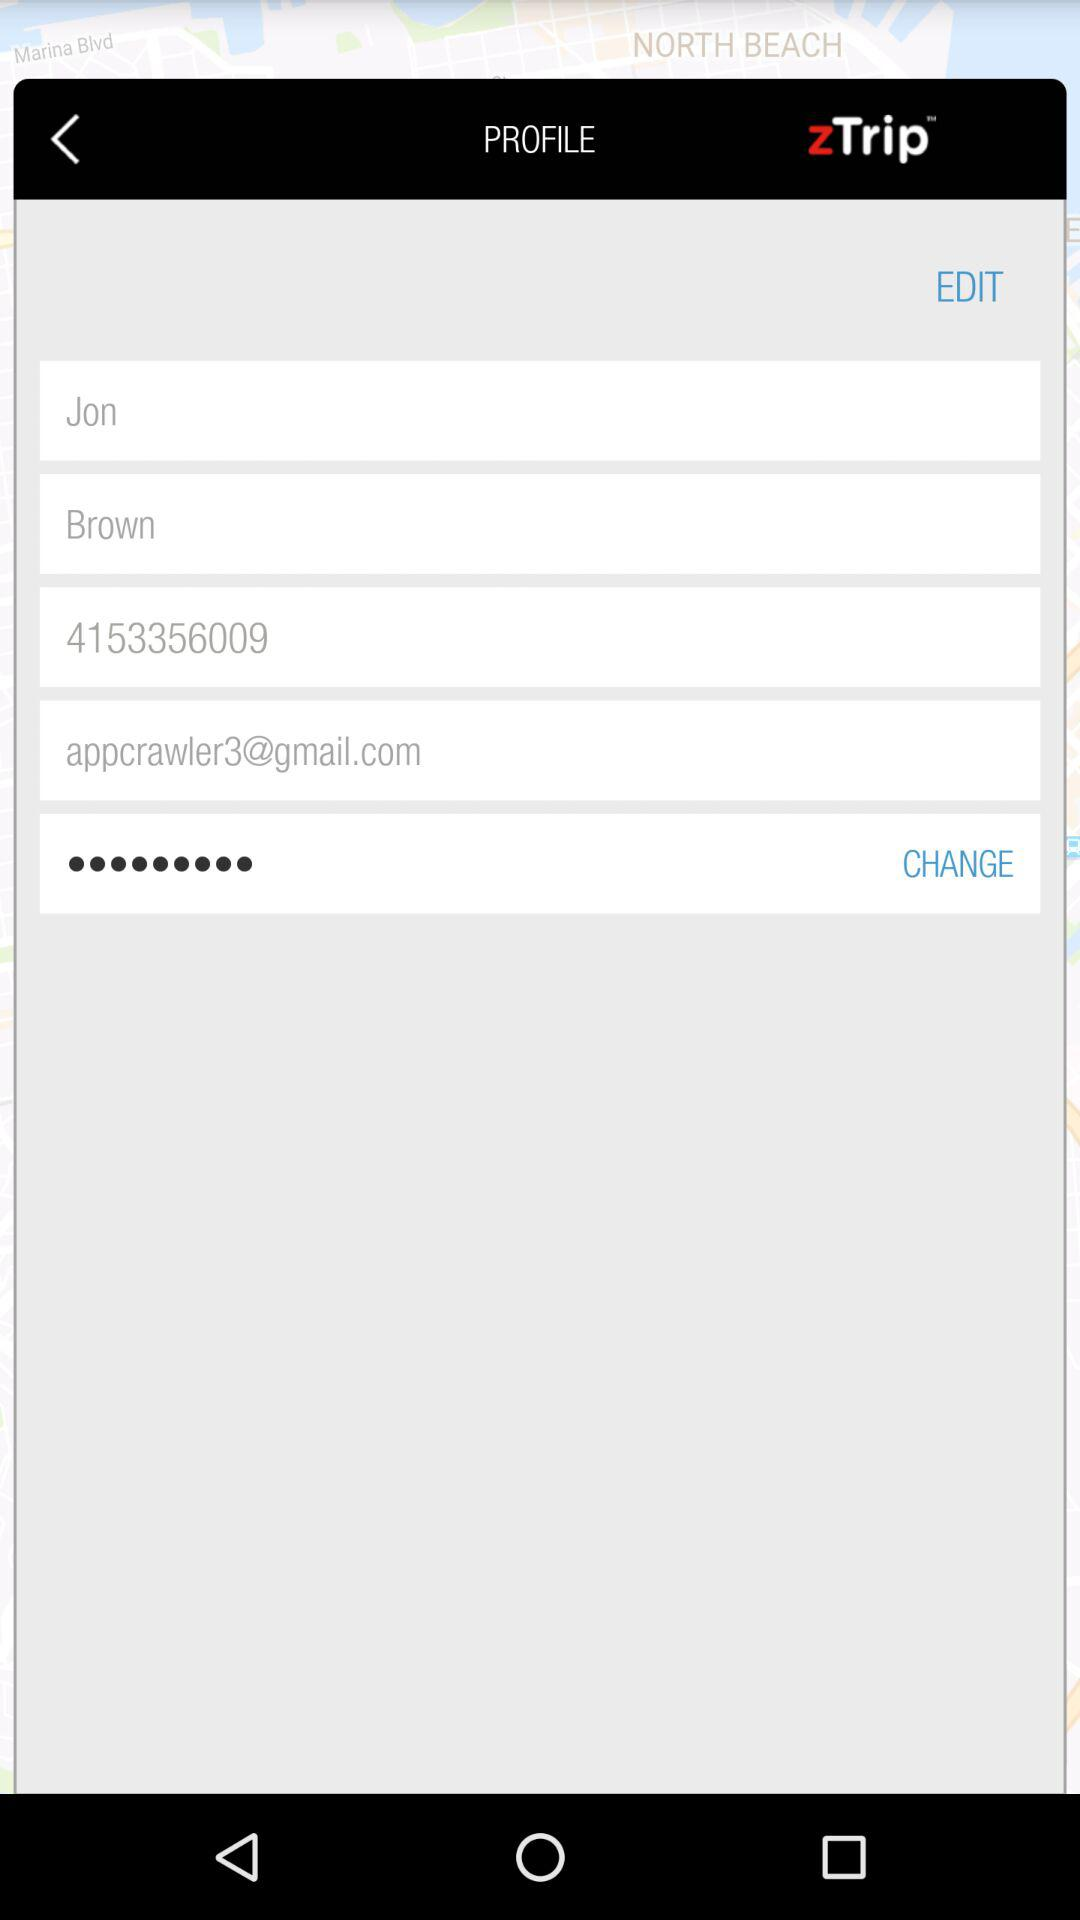What is the email address? The email address is appcrawler3@gmail.com. 